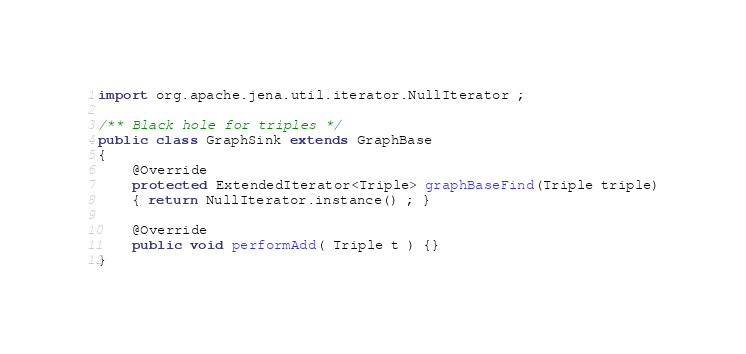Convert code to text. <code><loc_0><loc_0><loc_500><loc_500><_Java_>import org.apache.jena.util.iterator.NullIterator ;

/** Black hole for triples */
public class GraphSink extends GraphBase
{
    @Override
    protected ExtendedIterator<Triple> graphBaseFind(Triple triple)
    { return NullIterator.instance() ; }
    
    @Override
    public void performAdd( Triple t ) {}
}
</code> 